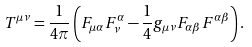Convert formula to latex. <formula><loc_0><loc_0><loc_500><loc_500>T ^ { \mu \nu } = \frac { 1 } { 4 \pi } \left ( F _ { \mu \alpha } F _ { \nu } ^ { \alpha } - \frac { 1 } { 4 } g _ { \mu \nu } F _ { \alpha \beta } F ^ { \alpha \beta } \right ) .</formula> 